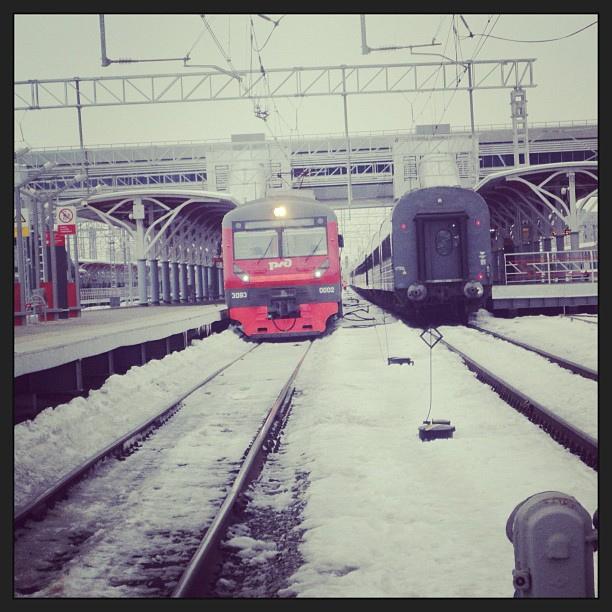Is it a cold day or a warm day in this photo?
Be succinct. Cold. What is the color of the train approaching?
Short answer required. Red. How many trains are there?
Short answer required. 2. When was the picture taken?
Answer briefly. Winter. 